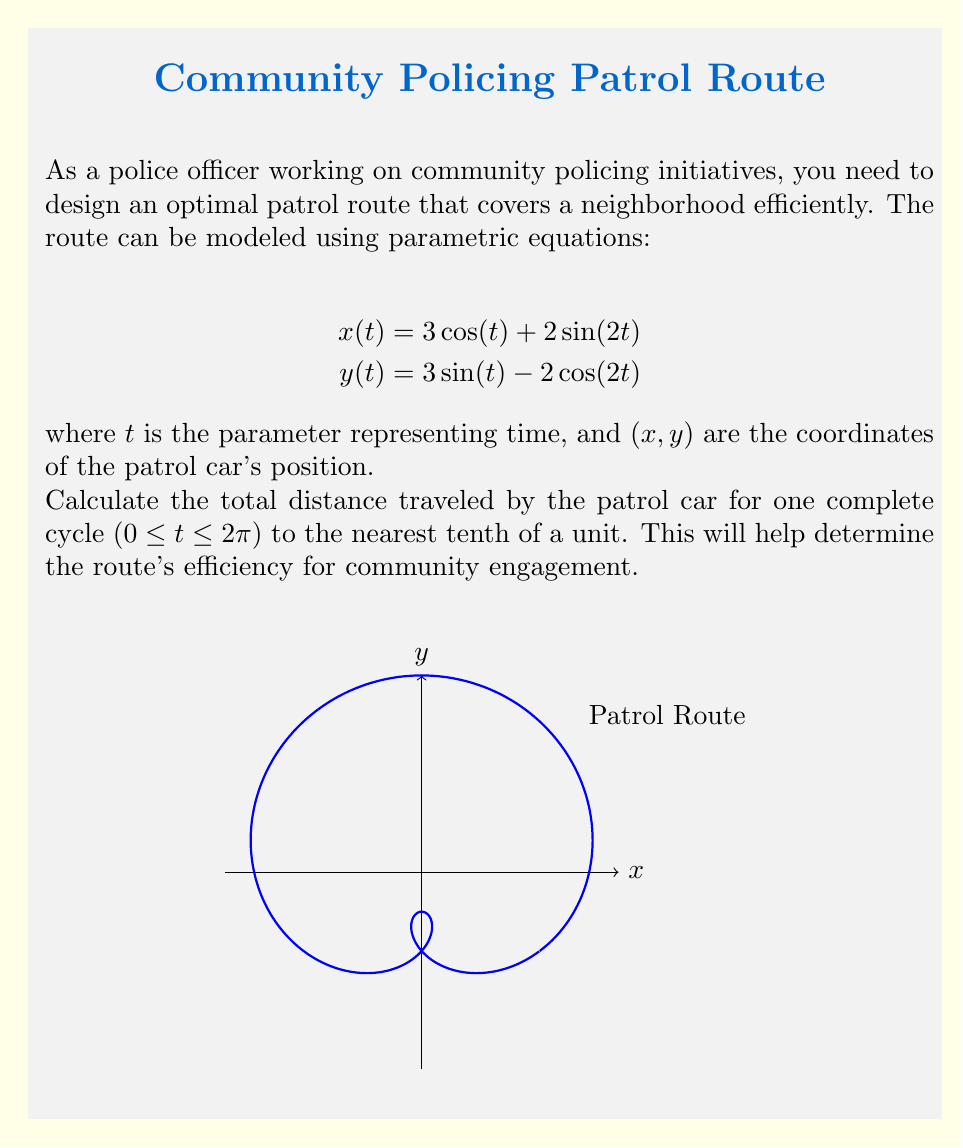What is the answer to this math problem? To find the total distance traveled, we need to calculate the arc length of the parametric curve. The formula for arc length is:

$$L = \int_a^b \sqrt{\left(\frac{dx}{dt}\right)^2 + \left(\frac{dy}{dt}\right)^2} dt$$

Step 1: Find $\frac{dx}{dt}$ and $\frac{dy}{dt}$
$$\frac{dx}{dt} = -3\sin(t) + 4\cos(2t)$$
$$\frac{dy}{dt} = 3\cos(t) + 4\sin(2t)$$

Step 2: Substitute into the arc length formula
$$L = \int_0^{2\pi} \sqrt{(-3\sin(t) + 4\cos(2t))^2 + (3\cos(t) + 4\sin(2t))^2} dt$$

Step 3: Simplify the expression under the square root
$$(-3\sin(t) + 4\cos(2t))^2 + (3\cos(t) + 4\sin(2t))^2$$
$$= 9\sin^2(t) + 24\sin(t)\cos(2t) + 16\cos^2(2t) + 9\cos^2(t) + 24\cos(t)\sin(2t) + 16\sin^2(2t)$$
$$= 9(\sin^2(t) + \cos^2(t)) + 16(\sin^2(2t) + \cos^2(2t)) + 24(\sin(t)\cos(2t) + \cos(t)\sin(2t))$$
$$= 9 + 16 + 24\sin(3t) = 25 + 24\sin(3t)$$

Step 4: Rewrite the integral
$$L = \int_0^{2\pi} \sqrt{25 + 24\sin(3t)} dt$$

Step 5: This integral cannot be solved analytically. We need to use numerical integration methods, such as the trapezoidal rule or Simpson's rule, to approximate the result.

Using a numerical integration tool or computer algebra system, we find:

$$L \approx 19.4$$

Rounding to the nearest tenth, we get 19.4 units.
Answer: 19.4 units 